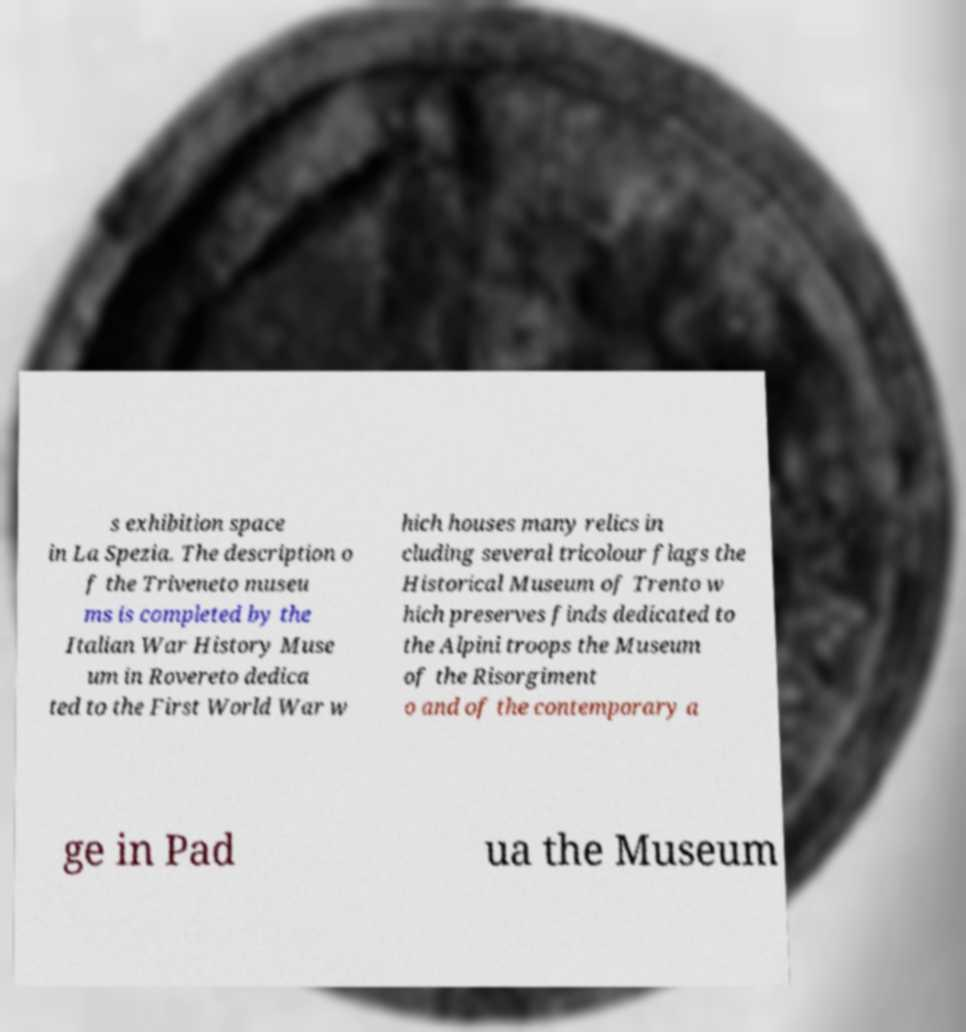I need the written content from this picture converted into text. Can you do that? s exhibition space in La Spezia. The description o f the Triveneto museu ms is completed by the Italian War History Muse um in Rovereto dedica ted to the First World War w hich houses many relics in cluding several tricolour flags the Historical Museum of Trento w hich preserves finds dedicated to the Alpini troops the Museum of the Risorgiment o and of the contemporary a ge in Pad ua the Museum 